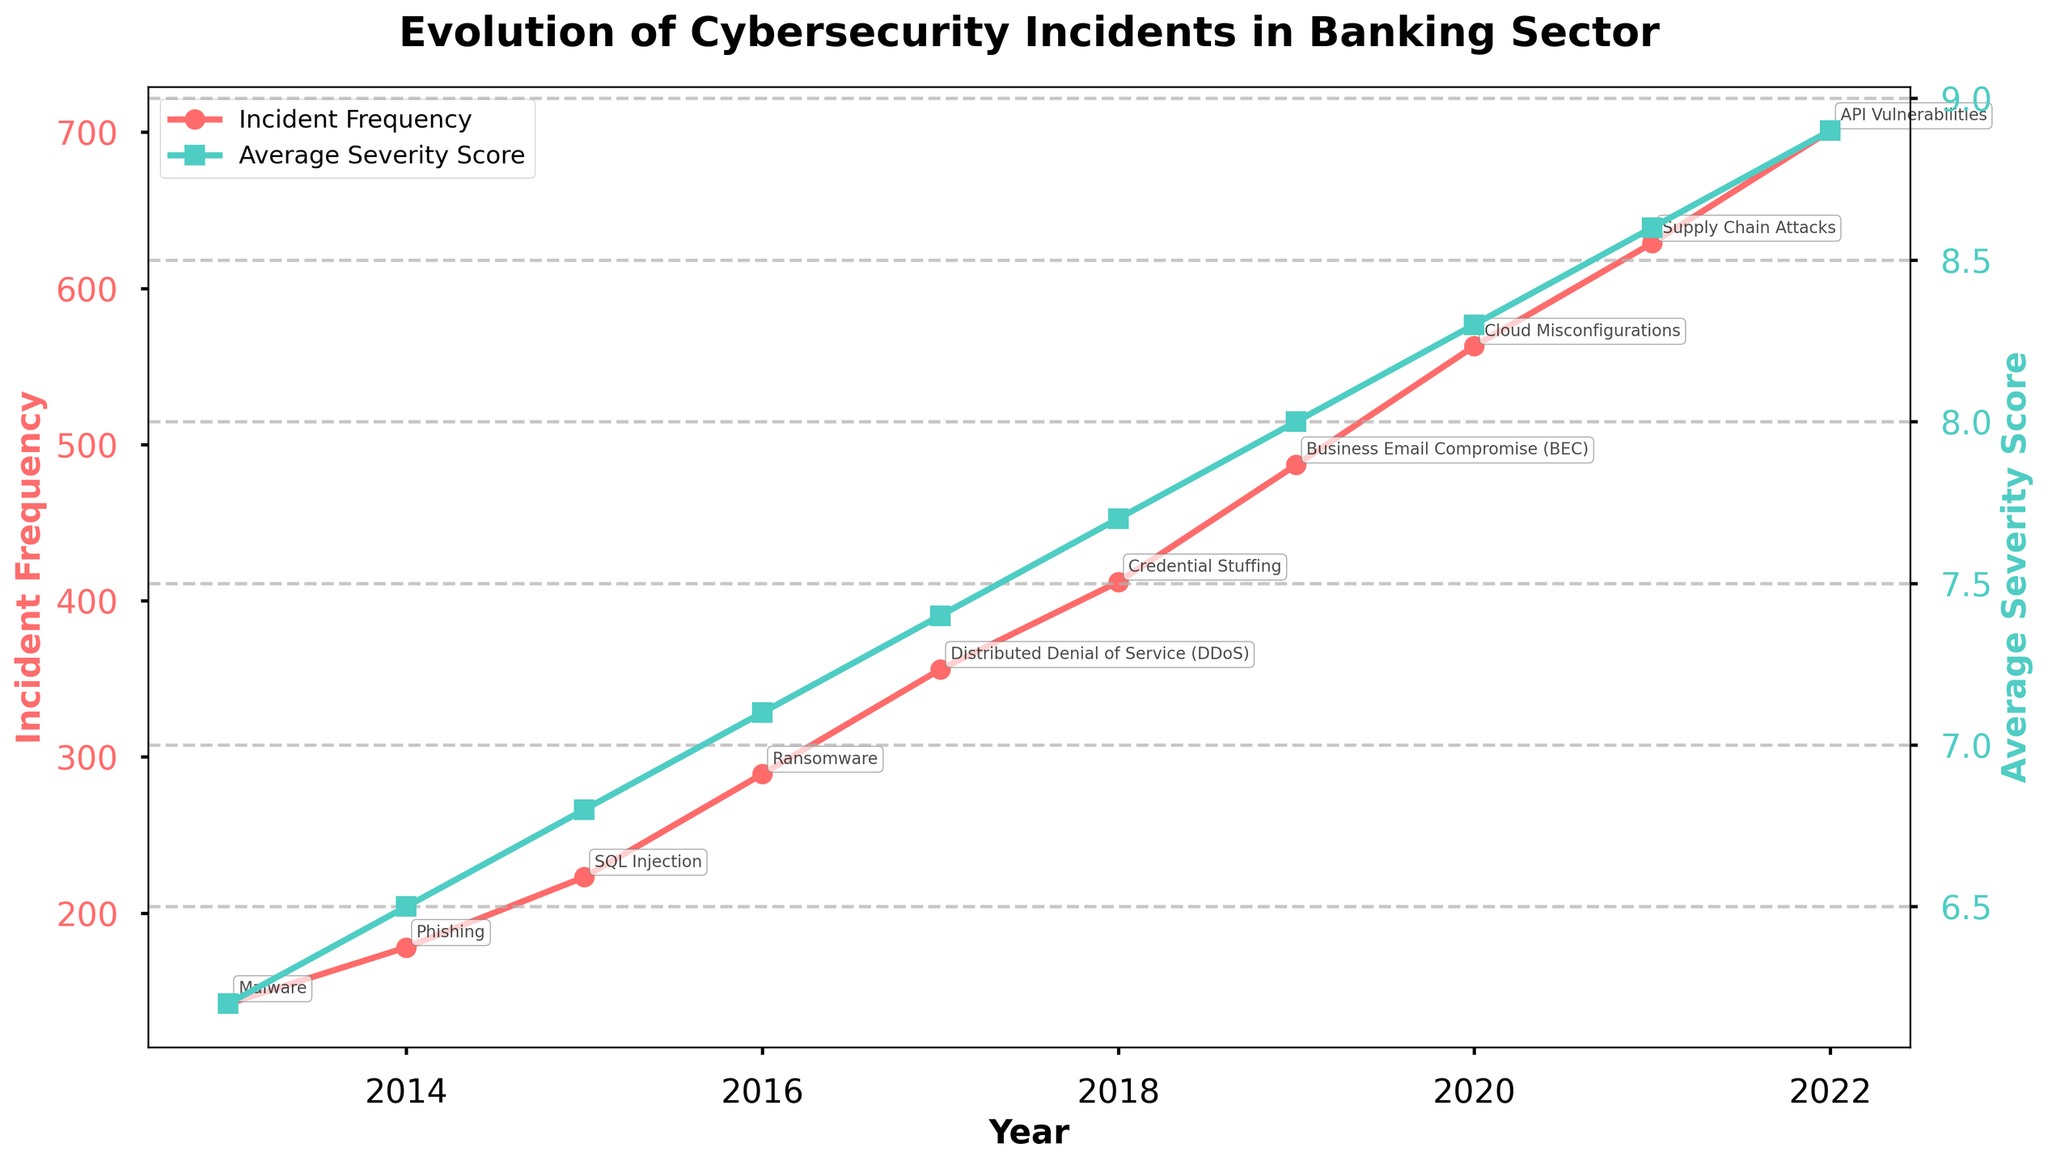What's the trend of incident frequency over the last decade? From the plot, observe the line representing "Incident Frequency" over the years. It shows a consistent upward trend from 2013 to 2022. The value increases each year, indicating a steady rise in the number of incidents.
Answer: Upward trend How does the average severity score change from 2013 to 2022? Observe the "Average Severity Score" line in the chart. It also shows a consistent upward trend, increasing each year from 6.2 in 2013 to 8.9 in 2022.
Answer: Increases steadily In which year was the incident frequency the highest, and what is the value? Identify the peak point on the "Incident Frequency" line. The highest point is in 2022, with a value of 701.
Answer: 2022, 701 Compare the growth rate in incident frequency from 2013 to 2017 and from 2018 to 2022. Which period had a higher growth rate? Calculate the change for each period: 2013 (142) to 2017 (356) and 2018 (412) to 2022 (701). 
2013-2017: 356 - 142 = 214
2018-2022: 701 - 412 = 289
The second period had a higher growth rate (289 compared to 214).
Answer: 2018-2022 Which year had the highest average severity score, and what vector was prominent that year? Locate the highest point on the "Average Severity Score" line, which is 2022 with a severity score of 8.9. The top attack vector that year was "API Vulnerabilities" as annotated in the chart.
Answer: 2022, API Vulnerabilities How did the total financial loss correlate with the incident frequency over the decade? Compare the trend of the financial loss (mentioned in the data) with the incident frequency trend in the plot. Both show an upward trend from 320M in 2013 to 4020M in 2022, indicating a positive correlation.
Answer: Positive correlation Which attack vector caused the highest incident frequency in any given year? Review the annotations for the highest incident frequency, which is 2022 (701 incidents), and note the top attack vector for that year, which is "API Vulnerabilities."
Answer: API Vulnerabilities in 2022 What's the difference in the average severity score between 2013 and 2022? Find the values for 2013 (6.2) and 2022 (8.9) from the "Average Severity Score" line in the plot. Calculate the difference: 8.9 - 6.2 = 2.7.
Answer: 2.7 Which years had a noticeable change in the attack vector annotations? Read through the annotations across years. Notable changes in attack vectors include switches each year: 2013 (Malware) to 2014 (Phishing), 2017 (DDoS) to 2018 (Credential Stuffing), and so forth.
Answer: Frequent changes across years 